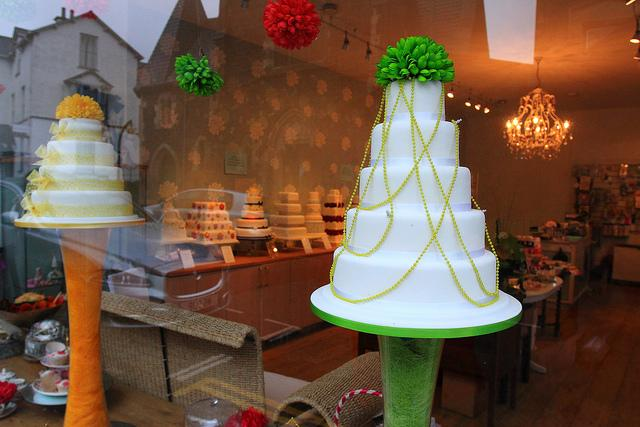What is inside of the large cake with green top and bottom? Please explain your reasoning. nothing. There is nothing inside. 